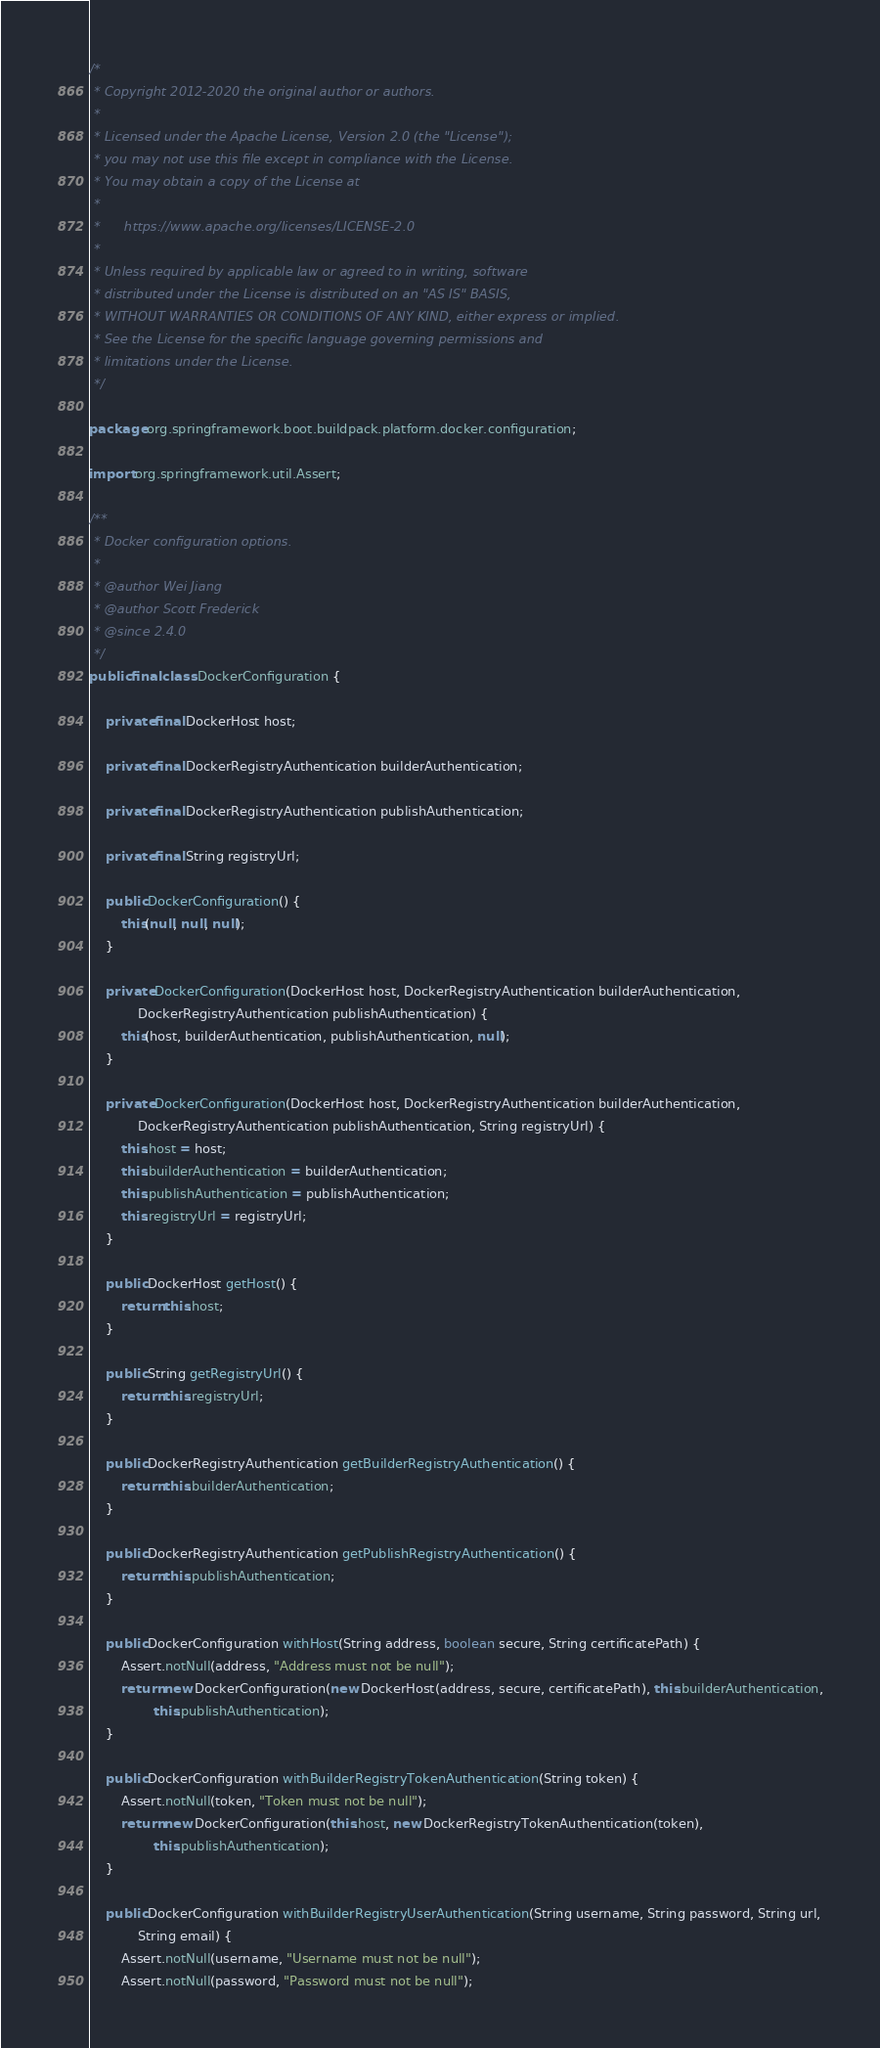Convert code to text. <code><loc_0><loc_0><loc_500><loc_500><_Java_>/*
 * Copyright 2012-2020 the original author or authors.
 *
 * Licensed under the Apache License, Version 2.0 (the "License");
 * you may not use this file except in compliance with the License.
 * You may obtain a copy of the License at
 *
 *      https://www.apache.org/licenses/LICENSE-2.0
 *
 * Unless required by applicable law or agreed to in writing, software
 * distributed under the License is distributed on an "AS IS" BASIS,
 * WITHOUT WARRANTIES OR CONDITIONS OF ANY KIND, either express or implied.
 * See the License for the specific language governing permissions and
 * limitations under the License.
 */

package org.springframework.boot.buildpack.platform.docker.configuration;

import org.springframework.util.Assert;

/**
 * Docker configuration options.
 *
 * @author Wei Jiang
 * @author Scott Frederick
 * @since 2.4.0
 */
public final class DockerConfiguration {

	private final DockerHost host;

	private final DockerRegistryAuthentication builderAuthentication;

	private final DockerRegistryAuthentication publishAuthentication;

	private final String registryUrl;

	public DockerConfiguration() {
		this(null, null, null);
	}

	private DockerConfiguration(DockerHost host, DockerRegistryAuthentication builderAuthentication,
			DockerRegistryAuthentication publishAuthentication) {
		this(host, builderAuthentication, publishAuthentication, null);
	}

	private DockerConfiguration(DockerHost host, DockerRegistryAuthentication builderAuthentication,
			DockerRegistryAuthentication publishAuthentication, String registryUrl) {
		this.host = host;
		this.builderAuthentication = builderAuthentication;
		this.publishAuthentication = publishAuthentication;
		this.registryUrl = registryUrl;
	}

	public DockerHost getHost() {
		return this.host;
	}

	public String getRegistryUrl() {
		return this.registryUrl;
	}

	public DockerRegistryAuthentication getBuilderRegistryAuthentication() {
		return this.builderAuthentication;
	}

	public DockerRegistryAuthentication getPublishRegistryAuthentication() {
		return this.publishAuthentication;
	}

	public DockerConfiguration withHost(String address, boolean secure, String certificatePath) {
		Assert.notNull(address, "Address must not be null");
		return new DockerConfiguration(new DockerHost(address, secure, certificatePath), this.builderAuthentication,
				this.publishAuthentication);
	}

	public DockerConfiguration withBuilderRegistryTokenAuthentication(String token) {
		Assert.notNull(token, "Token must not be null");
		return new DockerConfiguration(this.host, new DockerRegistryTokenAuthentication(token),
				this.publishAuthentication);
	}

	public DockerConfiguration withBuilderRegistryUserAuthentication(String username, String password, String url,
			String email) {
		Assert.notNull(username, "Username must not be null");
		Assert.notNull(password, "Password must not be null");</code> 